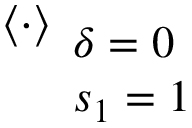<formula> <loc_0><loc_0><loc_500><loc_500>\langle \cdot \rangle _ { \begin{array} { l } { \delta = 0 } \\ { s _ { 1 } = 1 } \end{array} }</formula> 